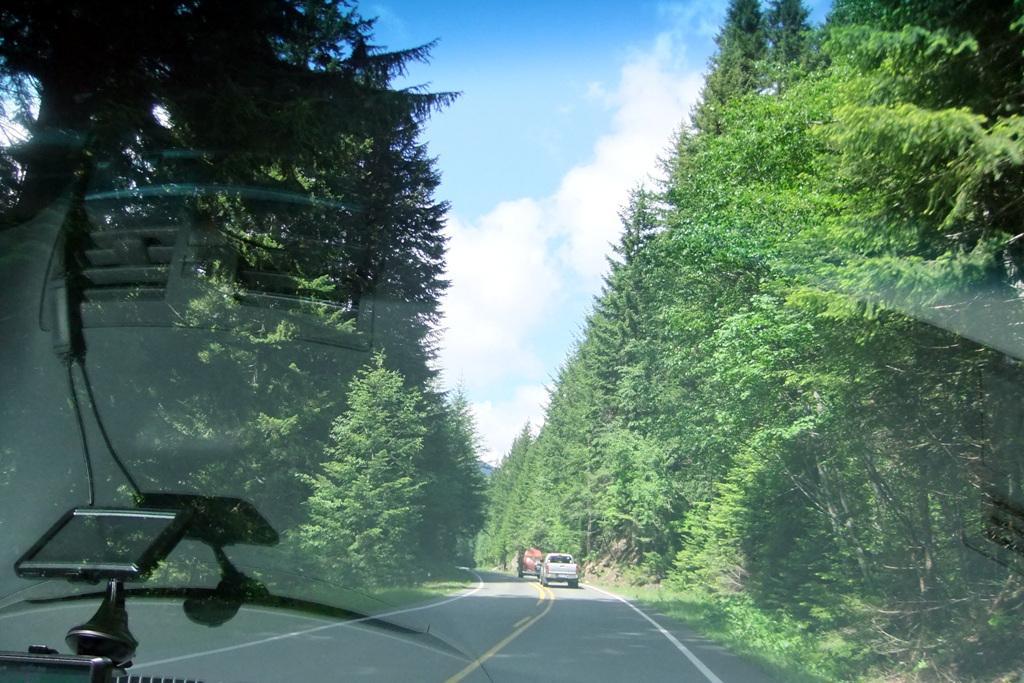Please provide a concise description of this image. This picture might be taken outside of the glass window. In this image, on the left corner, inside the glass window, we can see a display. Outside of the glass window, on the right side, we can see some trees, plants. On the left side of the glass window, we can see some trees and plants. In the middle, outside of the glass window, we can see few vehicles are moving on the road. On the top, we can see a sky, at the bottom there is a road. 